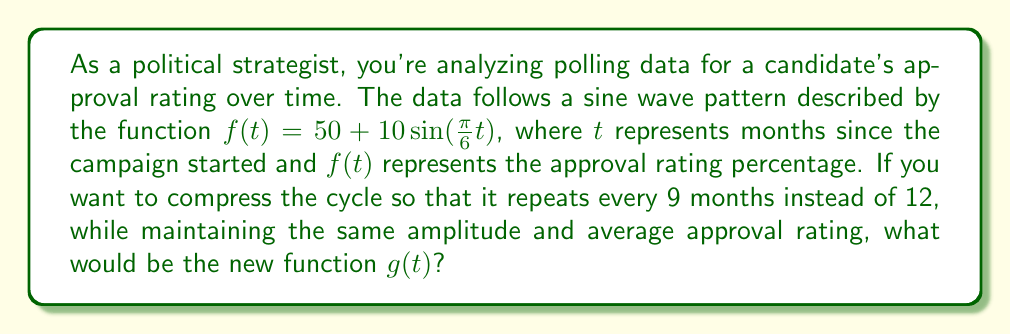Help me with this question. To solve this problem, we need to follow these steps:

1) First, let's understand the given function:
   $f(t) = 50 + 10\sin(\frac{\pi}{6}t)$
   - 50 is the average approval rating
   - 10 is the amplitude
   - $\frac{\pi}{6}$ is the frequency (as $2\pi$ divided by the period of 12 months)

2) We want to keep the average (50) and amplitude (10) the same, but change the period from 12 months to 9 months.

3) To change the period, we need to adjust the frequency inside the sine function. The new frequency will be $\frac{2\pi}{9}$.

4) Therefore, we need to replace $\frac{\pi}{6}$ with $\frac{2\pi}{9}$ in our function.

5) The new function $g(t)$ will be:
   $g(t) = 50 + 10\sin(\frac{2\pi}{9}t)$

This new function will have the same average approval rating and amplitude, but will complete a full cycle every 9 months instead of 12.
Answer: $g(t) = 50 + 10\sin(\frac{2\pi}{9}t)$ 